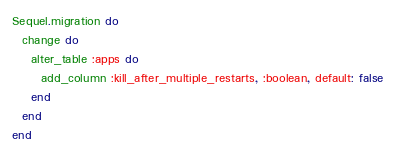<code> <loc_0><loc_0><loc_500><loc_500><_Ruby_>Sequel.migration do
  change do
    alter_table :apps do
      add_column :kill_after_multiple_restarts, :boolean, default: false
    end
  end
end
</code> 